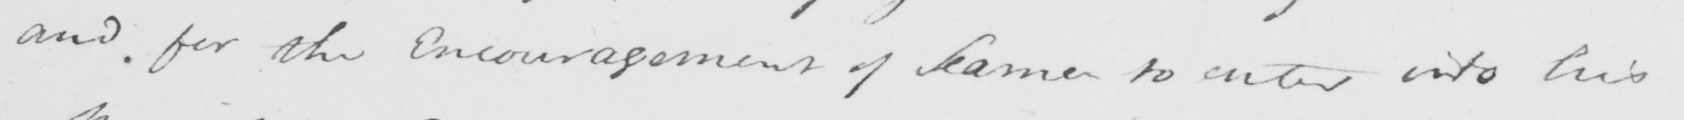What text is written in this handwritten line? and for the encouragement of Same to enter into his 